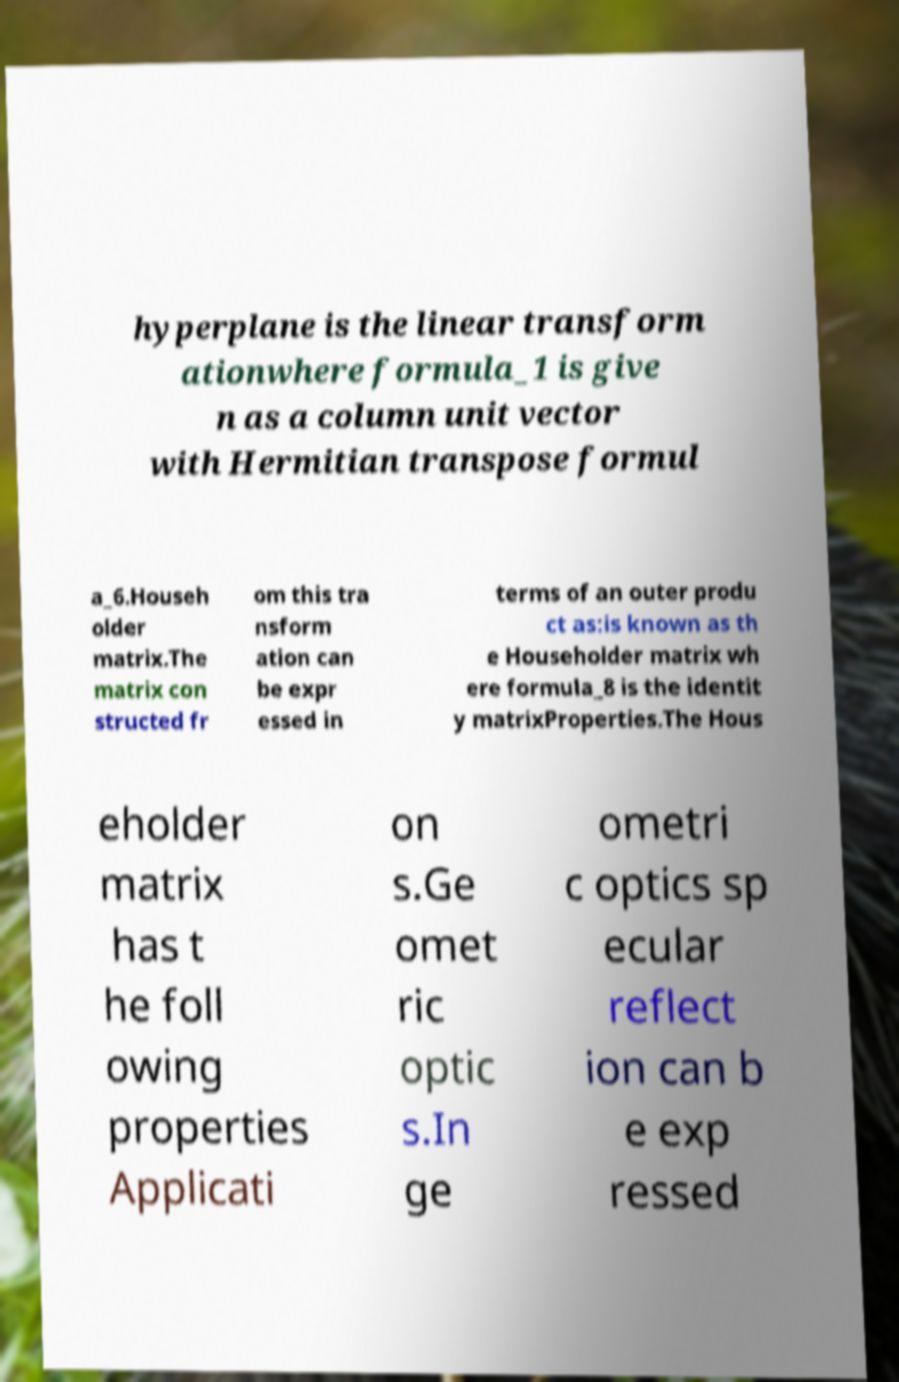For documentation purposes, I need the text within this image transcribed. Could you provide that? hyperplane is the linear transform ationwhere formula_1 is give n as a column unit vector with Hermitian transpose formul a_6.Househ older matrix.The matrix con structed fr om this tra nsform ation can be expr essed in terms of an outer produ ct as:is known as th e Householder matrix wh ere formula_8 is the identit y matrixProperties.The Hous eholder matrix has t he foll owing properties Applicati on s.Ge omet ric optic s.In ge ometri c optics sp ecular reflect ion can b e exp ressed 